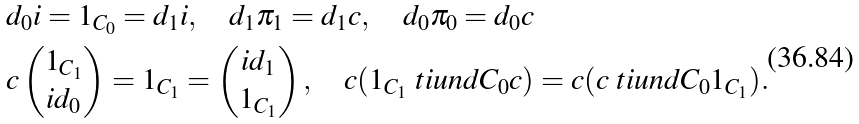<formula> <loc_0><loc_0><loc_500><loc_500>& d _ { 0 } i = 1 _ { C _ { 0 } } = d _ { 1 } i , \quad d _ { 1 } \pi _ { 1 } = d _ { 1 } c , \quad d _ { 0 } \pi _ { 0 } = d _ { 0 } c \\ & c \left ( \begin{matrix} 1 _ { C _ { 1 } } \\ i d _ { 0 } \end{matrix} \right ) = 1 _ { C _ { 1 } } = \left ( \begin{matrix} i d _ { 1 } \\ 1 _ { C _ { 1 } } \end{matrix} \right ) , \quad c ( 1 _ { C _ { 1 } } \ t i u n d { C _ { 0 } } c ) = c ( c \ t i u n d { C _ { 0 } } 1 _ { C _ { 1 } } ) .</formula> 